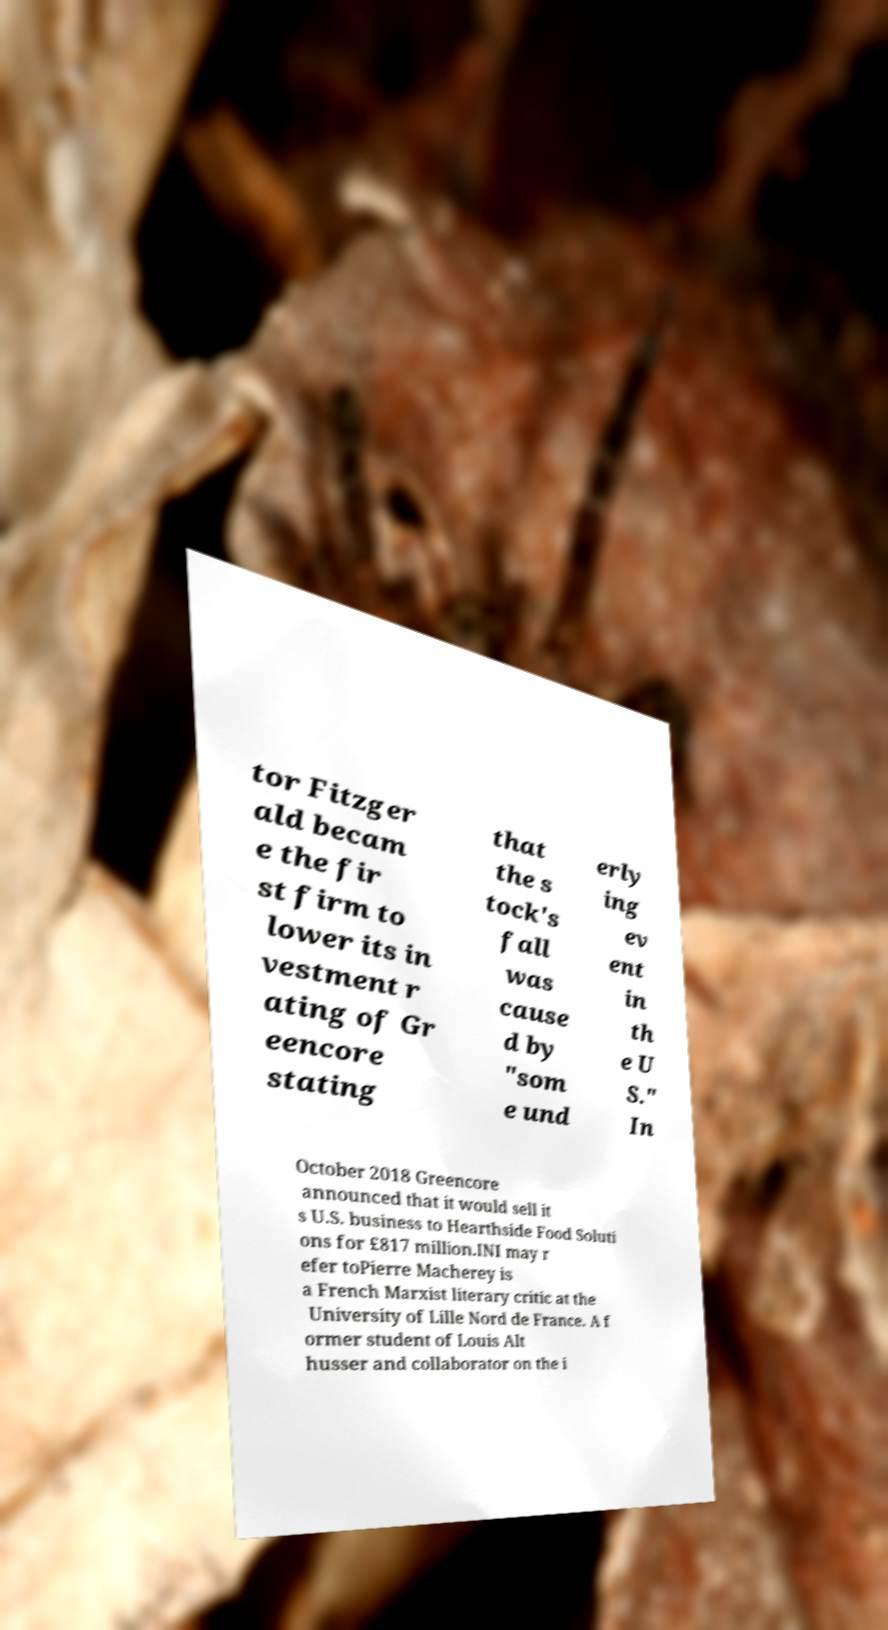Could you extract and type out the text from this image? tor Fitzger ald becam e the fir st firm to lower its in vestment r ating of Gr eencore stating that the s tock's fall was cause d by "som e und erly ing ev ent in th e U S." In October 2018 Greencore announced that it would sell it s U.S. business to Hearthside Food Soluti ons for £817 million.INI may r efer toPierre Macherey is a French Marxist literary critic at the University of Lille Nord de France. A f ormer student of Louis Alt husser and collaborator on the i 